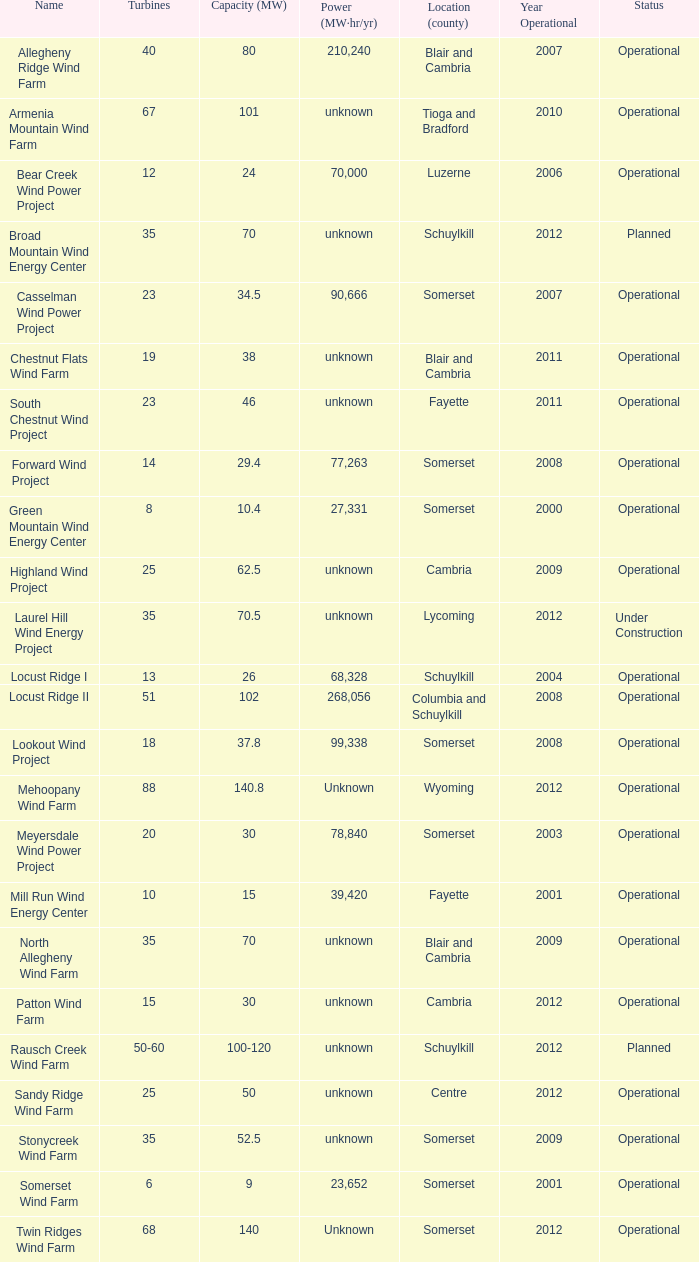What various capabilities do turbines have between 50-60? 100-120. 